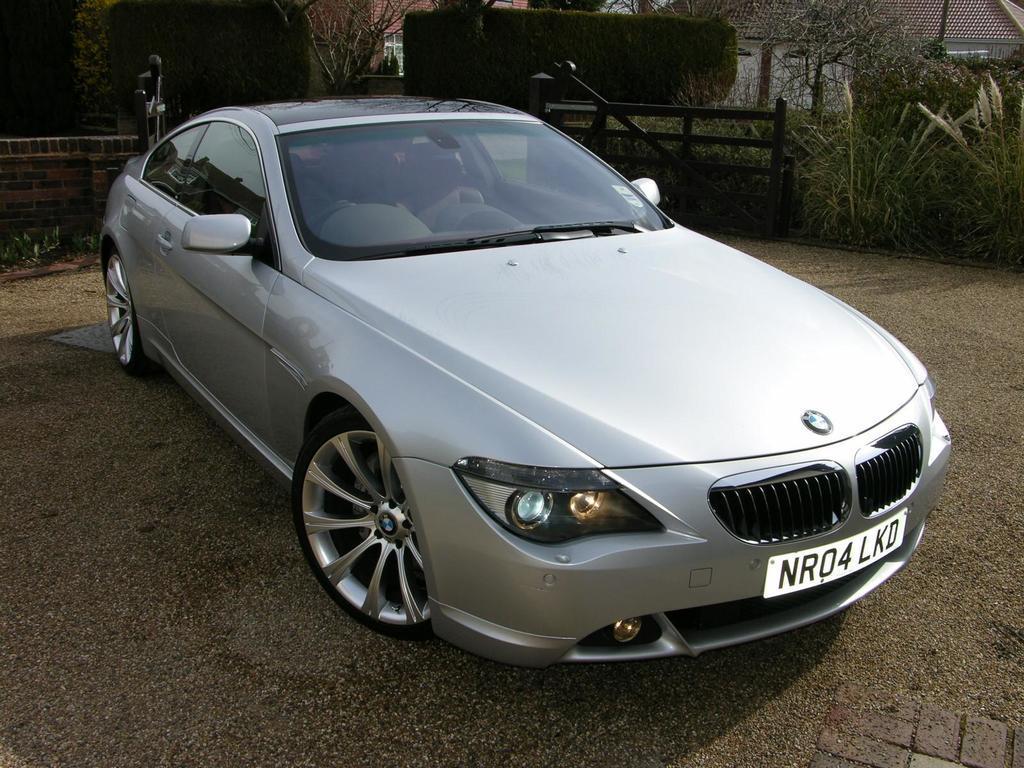Describe this image in one or two sentences. In this image we can see a car parked on the road surface, behind the car we can see trees and houses. 